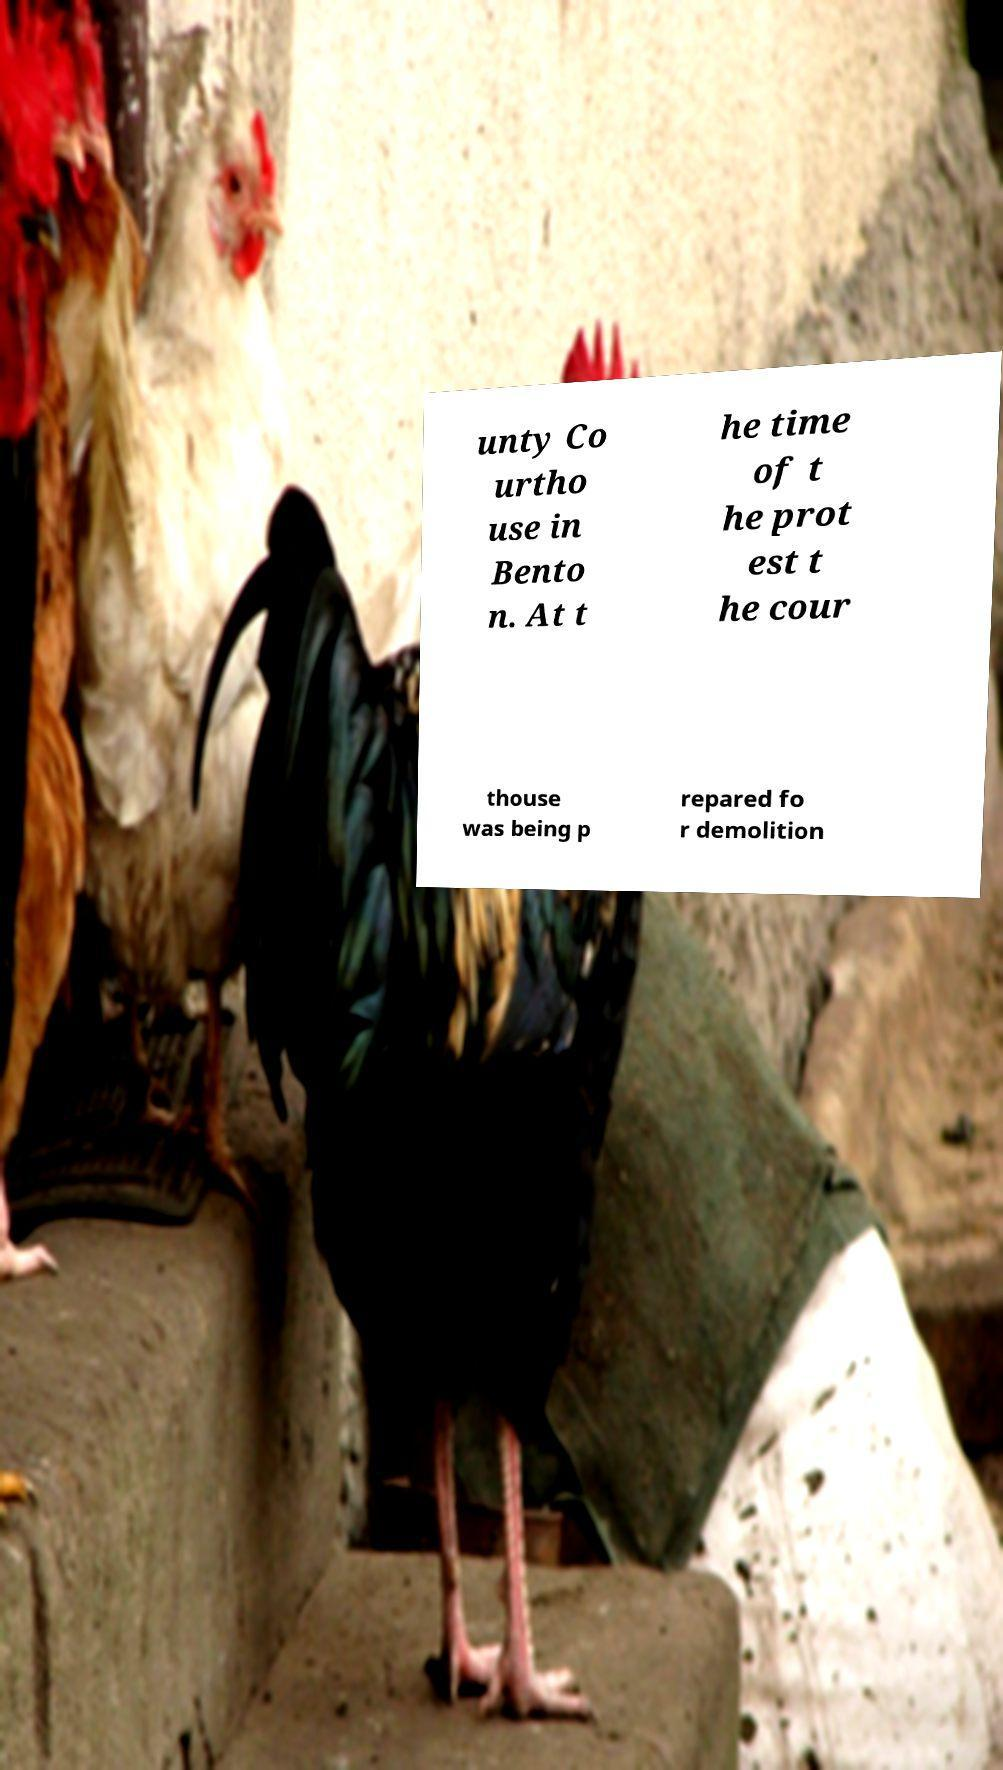Could you extract and type out the text from this image? unty Co urtho use in Bento n. At t he time of t he prot est t he cour thouse was being p repared fo r demolition 